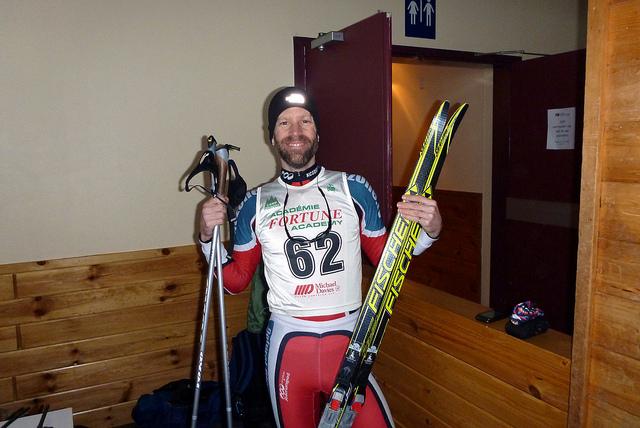What does the sign over the door indicate?
Write a very short answer. Restrooms. What is this person holding?
Give a very brief answer. Skis. What sport does this man like?
Concise answer only. Skiing. 